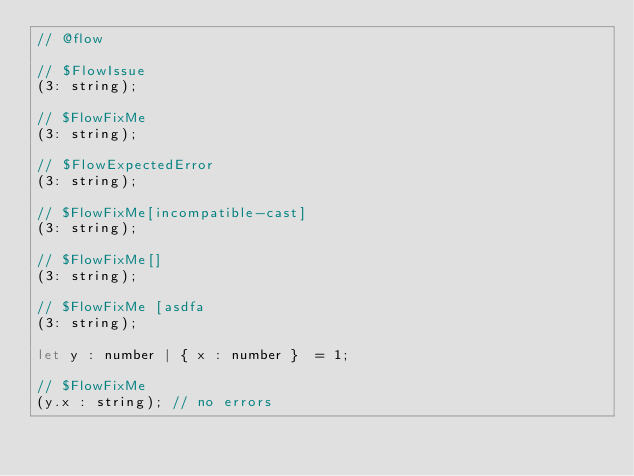<code> <loc_0><loc_0><loc_500><loc_500><_JavaScript_>// @flow

// $FlowIssue
(3: string);

// $FlowFixMe
(3: string);

// $FlowExpectedError
(3: string);

// $FlowFixMe[incompatible-cast]
(3: string);

// $FlowFixMe[]
(3: string);

// $FlowFixMe [asdfa
(3: string);

let y : number | { x : number }  = 1;

// $FlowFixMe
(y.x : string); // no errors
</code> 